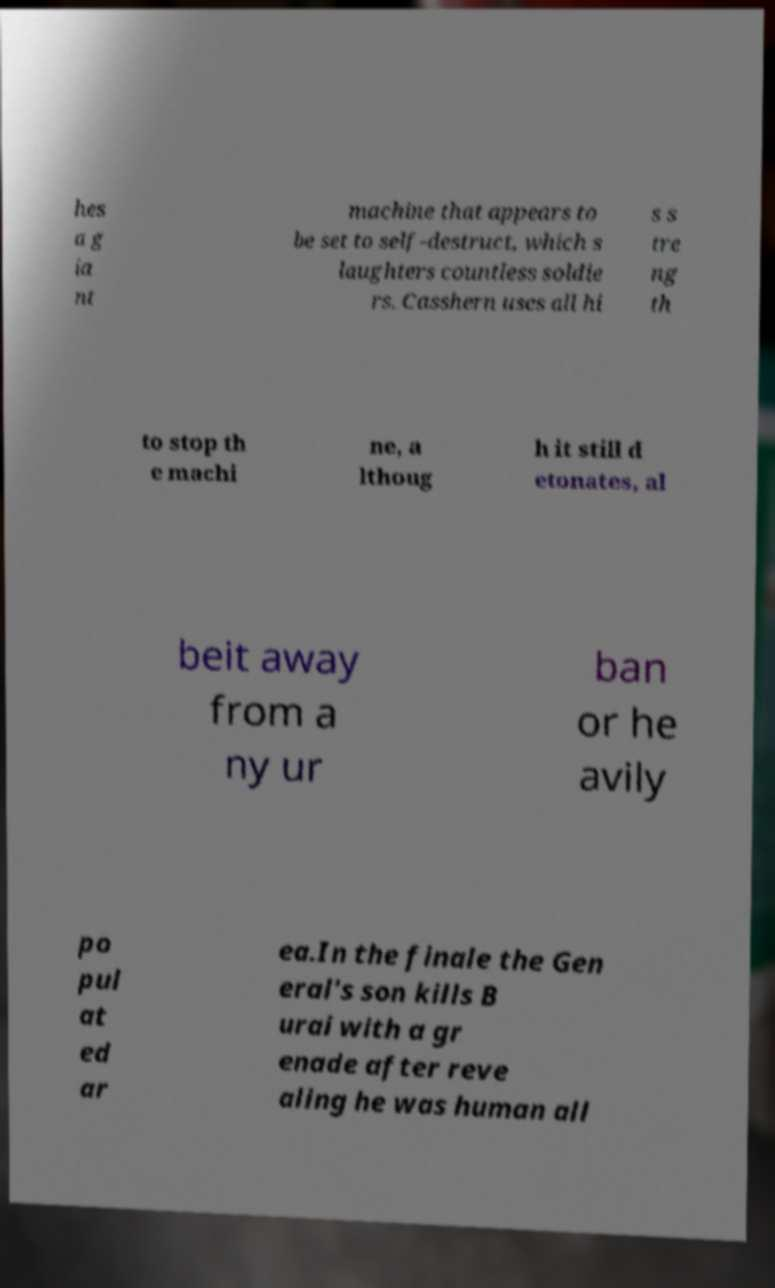Can you accurately transcribe the text from the provided image for me? hes a g ia nt machine that appears to be set to self-destruct, which s laughters countless soldie rs. Casshern uses all hi s s tre ng th to stop th e machi ne, a lthoug h it still d etonates, al beit away from a ny ur ban or he avily po pul at ed ar ea.In the finale the Gen eral's son kills B urai with a gr enade after reve aling he was human all 